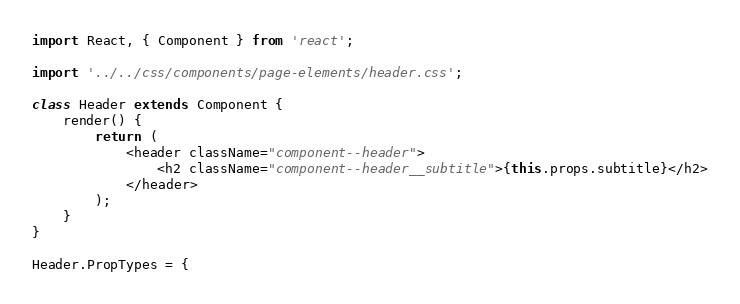<code> <loc_0><loc_0><loc_500><loc_500><_JavaScript_>import React, { Component } from 'react';

import '../../css/components/page-elements/header.css';

class Header extends Component {
    render() {
        return (
            <header className="component--header">
                <h2 className="component--header__subtitle">{this.props.subtitle}</h2>
            </header>
        );
    }
}

Header.PropTypes = {</code> 